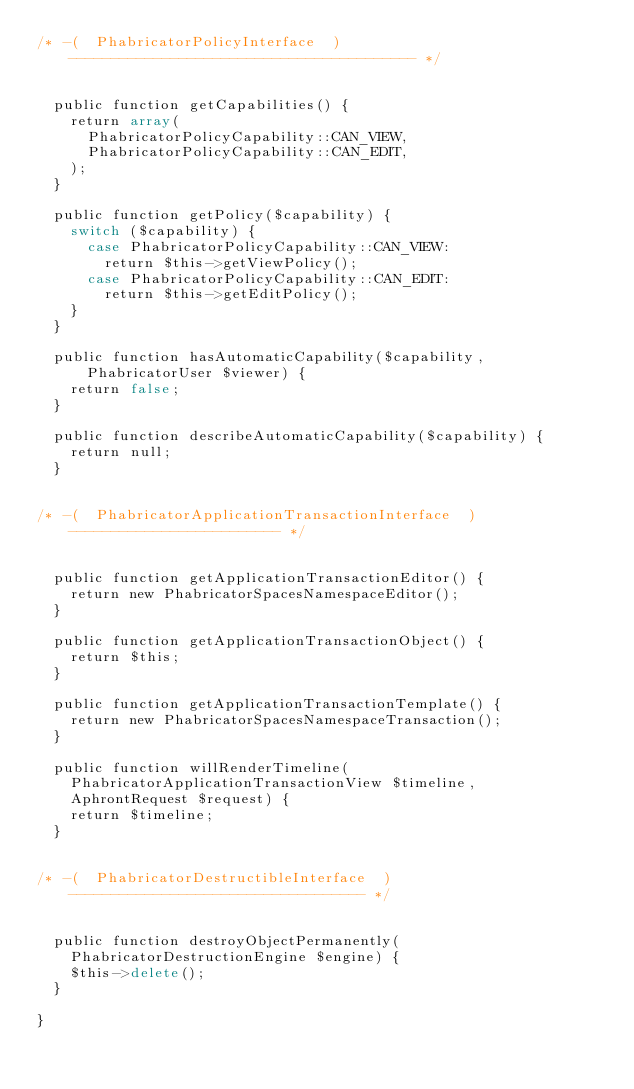Convert code to text. <code><loc_0><loc_0><loc_500><loc_500><_PHP_>/* -(  PhabricatorPolicyInterface  )----------------------------------------- */


  public function getCapabilities() {
    return array(
      PhabricatorPolicyCapability::CAN_VIEW,
      PhabricatorPolicyCapability::CAN_EDIT,
    );
  }

  public function getPolicy($capability) {
    switch ($capability) {
      case PhabricatorPolicyCapability::CAN_VIEW:
        return $this->getViewPolicy();
      case PhabricatorPolicyCapability::CAN_EDIT:
        return $this->getEditPolicy();
    }
  }

  public function hasAutomaticCapability($capability, PhabricatorUser $viewer) {
    return false;
  }

  public function describeAutomaticCapability($capability) {
    return null;
  }


/* -(  PhabricatorApplicationTransactionInterface  )------------------------- */


  public function getApplicationTransactionEditor() {
    return new PhabricatorSpacesNamespaceEditor();
  }

  public function getApplicationTransactionObject() {
    return $this;
  }

  public function getApplicationTransactionTemplate() {
    return new PhabricatorSpacesNamespaceTransaction();
  }

  public function willRenderTimeline(
    PhabricatorApplicationTransactionView $timeline,
    AphrontRequest $request) {
    return $timeline;
  }


/* -(  PhabricatorDestructibleInterface  )----------------------------------- */


  public function destroyObjectPermanently(
    PhabricatorDestructionEngine $engine) {
    $this->delete();
  }

}
</code> 